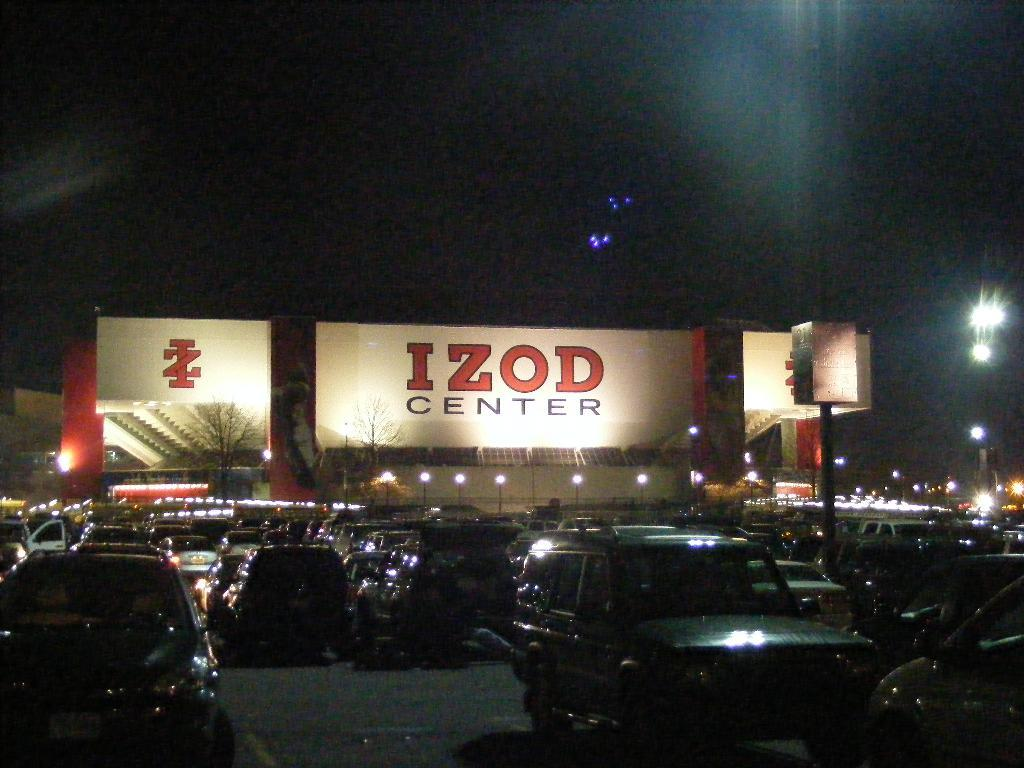What type of vehicles can be seen in the image? There are cars in the image. What natural elements are present in the image? There are trees in the image. What man-made structures can be seen in the image? There are poles and fencing in the image. What additional object with text is visible in the image? There is a board with text in the image. What type of illumination is present in the image? There are lights in the image. What part of the natural environment is visible in the image? The sky is visible in the image. How many visitors can be seen interacting with the tramp in the image? There is no tramp or visitors present in the image. What type of clothing is the beggar wearing in the image? There is no beggar present in the image. 